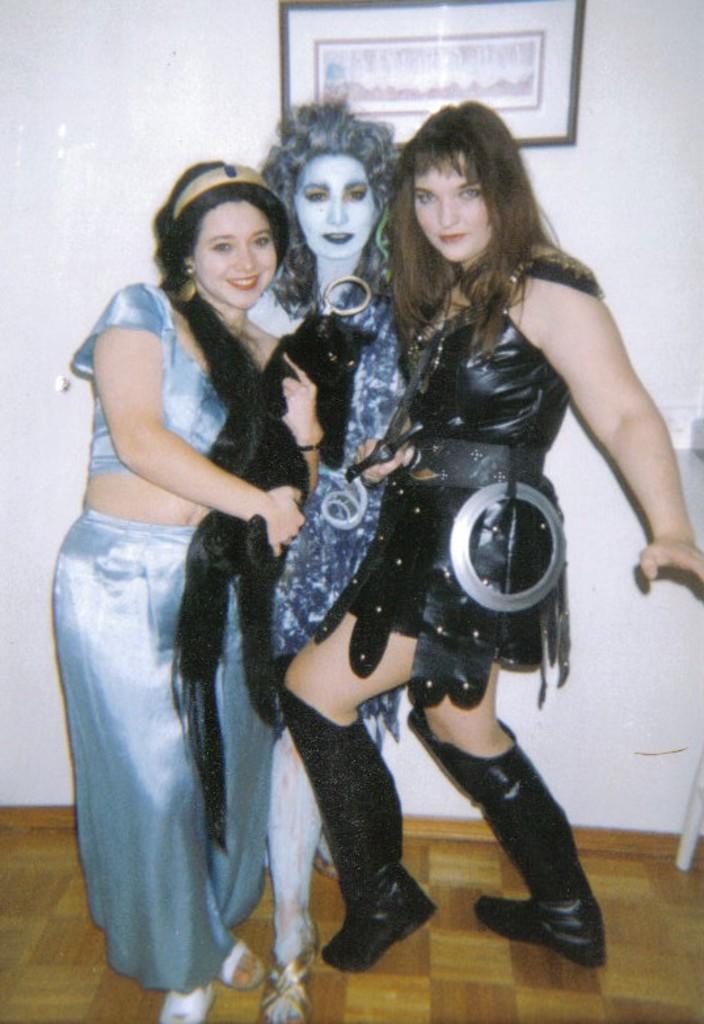Can you describe this image briefly? In this image there are persons standing and smiling. In the background there is a wall and on the wall there is a frame. 